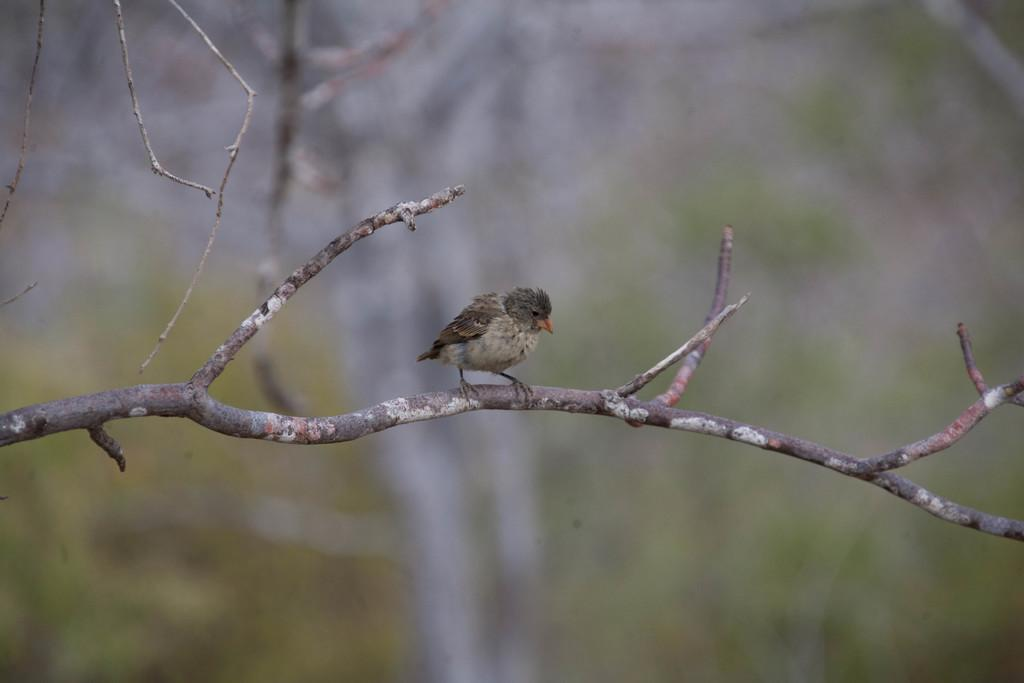What can be seen in the image? There is a branch in the image, and a bird is on the branch. Can you describe the bird's location? The bird is on the branch in the image. What can be observed about the background of the image? The background of the image is blurred. What song is the bird singing in the image? There is no indication in the image that the bird is singing a song, so it cannot be determined from the picture. 